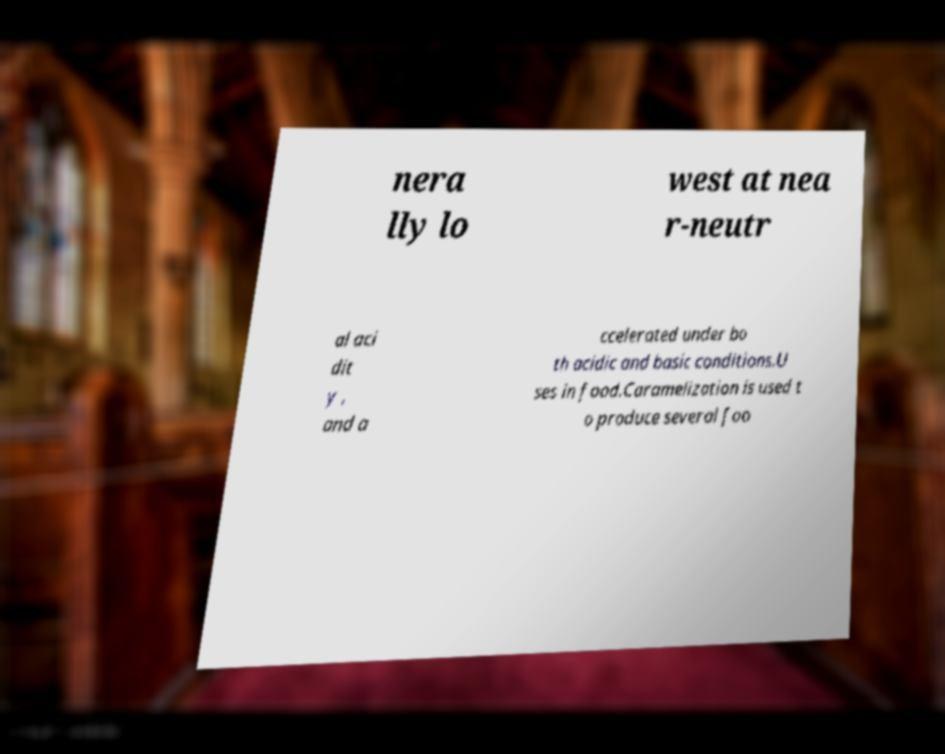Please identify and transcribe the text found in this image. nera lly lo west at nea r-neutr al aci dit y , and a ccelerated under bo th acidic and basic conditions.U ses in food.Caramelization is used t o produce several foo 